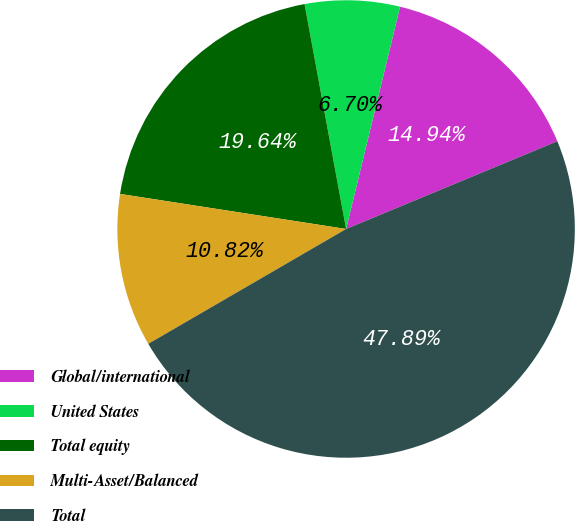<chart> <loc_0><loc_0><loc_500><loc_500><pie_chart><fcel>Global/international<fcel>United States<fcel>Total equity<fcel>Multi-Asset/Balanced<fcel>Total<nl><fcel>14.94%<fcel>6.7%<fcel>19.64%<fcel>10.82%<fcel>47.89%<nl></chart> 